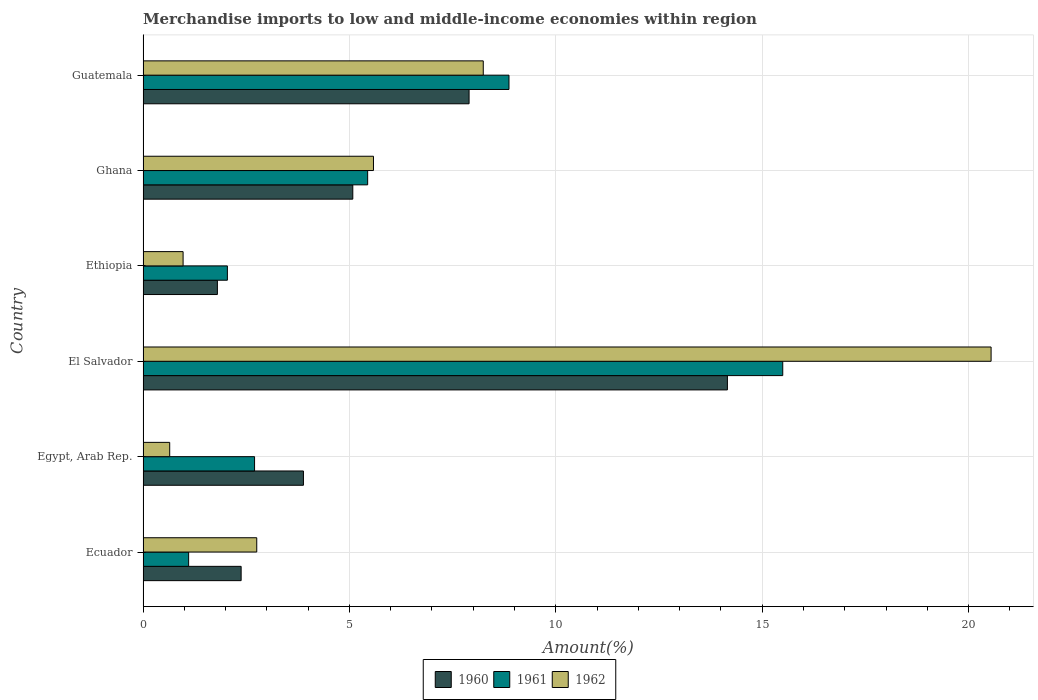Are the number of bars per tick equal to the number of legend labels?
Your response must be concise. Yes. Are the number of bars on each tick of the Y-axis equal?
Make the answer very short. Yes. How many bars are there on the 2nd tick from the bottom?
Provide a succinct answer. 3. What is the label of the 5th group of bars from the top?
Ensure brevity in your answer.  Egypt, Arab Rep. In how many cases, is the number of bars for a given country not equal to the number of legend labels?
Make the answer very short. 0. What is the percentage of amount earned from merchandise imports in 1961 in Ghana?
Offer a very short reply. 5.44. Across all countries, what is the maximum percentage of amount earned from merchandise imports in 1961?
Your answer should be very brief. 15.5. Across all countries, what is the minimum percentage of amount earned from merchandise imports in 1962?
Your answer should be very brief. 0.65. In which country was the percentage of amount earned from merchandise imports in 1961 maximum?
Provide a short and direct response. El Salvador. In which country was the percentage of amount earned from merchandise imports in 1962 minimum?
Your answer should be compact. Egypt, Arab Rep. What is the total percentage of amount earned from merchandise imports in 1960 in the graph?
Provide a short and direct response. 35.2. What is the difference between the percentage of amount earned from merchandise imports in 1961 in El Salvador and that in Ethiopia?
Keep it short and to the point. 13.46. What is the difference between the percentage of amount earned from merchandise imports in 1960 in El Salvador and the percentage of amount earned from merchandise imports in 1961 in Ethiopia?
Give a very brief answer. 12.11. What is the average percentage of amount earned from merchandise imports in 1960 per country?
Offer a very short reply. 5.87. What is the difference between the percentage of amount earned from merchandise imports in 1962 and percentage of amount earned from merchandise imports in 1960 in Ethiopia?
Offer a very short reply. -0.83. What is the ratio of the percentage of amount earned from merchandise imports in 1960 in Egypt, Arab Rep. to that in Ethiopia?
Offer a very short reply. 2.16. Is the percentage of amount earned from merchandise imports in 1960 in Egypt, Arab Rep. less than that in Ghana?
Provide a short and direct response. Yes. What is the difference between the highest and the second highest percentage of amount earned from merchandise imports in 1962?
Make the answer very short. 12.3. What is the difference between the highest and the lowest percentage of amount earned from merchandise imports in 1961?
Your answer should be compact. 14.39. In how many countries, is the percentage of amount earned from merchandise imports in 1961 greater than the average percentage of amount earned from merchandise imports in 1961 taken over all countries?
Your answer should be very brief. 2. Is the sum of the percentage of amount earned from merchandise imports in 1960 in Ecuador and Guatemala greater than the maximum percentage of amount earned from merchandise imports in 1962 across all countries?
Ensure brevity in your answer.  No. What does the 2nd bar from the bottom in El Salvador represents?
Provide a short and direct response. 1961. Is it the case that in every country, the sum of the percentage of amount earned from merchandise imports in 1961 and percentage of amount earned from merchandise imports in 1962 is greater than the percentage of amount earned from merchandise imports in 1960?
Provide a short and direct response. No. How many bars are there?
Your answer should be very brief. 18. How many countries are there in the graph?
Offer a terse response. 6. Does the graph contain any zero values?
Provide a short and direct response. No. How are the legend labels stacked?
Provide a short and direct response. Horizontal. What is the title of the graph?
Ensure brevity in your answer.  Merchandise imports to low and middle-income economies within region. What is the label or title of the X-axis?
Keep it short and to the point. Amount(%). What is the Amount(%) in 1960 in Ecuador?
Keep it short and to the point. 2.38. What is the Amount(%) in 1961 in Ecuador?
Provide a short and direct response. 1.1. What is the Amount(%) of 1962 in Ecuador?
Your answer should be compact. 2.75. What is the Amount(%) in 1960 in Egypt, Arab Rep.?
Give a very brief answer. 3.89. What is the Amount(%) of 1961 in Egypt, Arab Rep.?
Offer a terse response. 2.7. What is the Amount(%) in 1962 in Egypt, Arab Rep.?
Provide a short and direct response. 0.65. What is the Amount(%) of 1960 in El Salvador?
Provide a succinct answer. 14.16. What is the Amount(%) of 1961 in El Salvador?
Your answer should be compact. 15.5. What is the Amount(%) in 1962 in El Salvador?
Your response must be concise. 20.55. What is the Amount(%) of 1960 in Ethiopia?
Make the answer very short. 1.8. What is the Amount(%) of 1961 in Ethiopia?
Keep it short and to the point. 2.04. What is the Amount(%) of 1962 in Ethiopia?
Offer a terse response. 0.97. What is the Amount(%) in 1960 in Ghana?
Provide a succinct answer. 5.08. What is the Amount(%) of 1961 in Ghana?
Keep it short and to the point. 5.44. What is the Amount(%) in 1962 in Ghana?
Offer a very short reply. 5.58. What is the Amount(%) in 1960 in Guatemala?
Your answer should be compact. 7.9. What is the Amount(%) in 1961 in Guatemala?
Make the answer very short. 8.87. What is the Amount(%) of 1962 in Guatemala?
Provide a succinct answer. 8.24. Across all countries, what is the maximum Amount(%) in 1960?
Provide a short and direct response. 14.16. Across all countries, what is the maximum Amount(%) of 1961?
Offer a very short reply. 15.5. Across all countries, what is the maximum Amount(%) in 1962?
Offer a terse response. 20.55. Across all countries, what is the minimum Amount(%) in 1960?
Ensure brevity in your answer.  1.8. Across all countries, what is the minimum Amount(%) of 1961?
Provide a succinct answer. 1.1. Across all countries, what is the minimum Amount(%) in 1962?
Provide a short and direct response. 0.65. What is the total Amount(%) in 1960 in the graph?
Your answer should be compact. 35.2. What is the total Amount(%) of 1961 in the graph?
Make the answer very short. 35.65. What is the total Amount(%) of 1962 in the graph?
Offer a very short reply. 38.74. What is the difference between the Amount(%) of 1960 in Ecuador and that in Egypt, Arab Rep.?
Provide a short and direct response. -1.51. What is the difference between the Amount(%) of 1961 in Ecuador and that in Egypt, Arab Rep.?
Your response must be concise. -1.6. What is the difference between the Amount(%) in 1962 in Ecuador and that in Egypt, Arab Rep.?
Offer a very short reply. 2.11. What is the difference between the Amount(%) of 1960 in Ecuador and that in El Salvador?
Offer a terse response. -11.78. What is the difference between the Amount(%) in 1961 in Ecuador and that in El Salvador?
Provide a succinct answer. -14.39. What is the difference between the Amount(%) in 1962 in Ecuador and that in El Salvador?
Provide a succinct answer. -17.79. What is the difference between the Amount(%) of 1960 in Ecuador and that in Ethiopia?
Provide a succinct answer. 0.58. What is the difference between the Amount(%) in 1961 in Ecuador and that in Ethiopia?
Make the answer very short. -0.94. What is the difference between the Amount(%) in 1962 in Ecuador and that in Ethiopia?
Ensure brevity in your answer.  1.78. What is the difference between the Amount(%) of 1960 in Ecuador and that in Ghana?
Your answer should be very brief. -2.71. What is the difference between the Amount(%) in 1961 in Ecuador and that in Ghana?
Make the answer very short. -4.34. What is the difference between the Amount(%) in 1962 in Ecuador and that in Ghana?
Keep it short and to the point. -2.83. What is the difference between the Amount(%) of 1960 in Ecuador and that in Guatemala?
Provide a short and direct response. -5.52. What is the difference between the Amount(%) of 1961 in Ecuador and that in Guatemala?
Your answer should be very brief. -7.76. What is the difference between the Amount(%) of 1962 in Ecuador and that in Guatemala?
Your answer should be compact. -5.49. What is the difference between the Amount(%) in 1960 in Egypt, Arab Rep. and that in El Salvador?
Provide a short and direct response. -10.27. What is the difference between the Amount(%) of 1961 in Egypt, Arab Rep. and that in El Salvador?
Your answer should be very brief. -12.8. What is the difference between the Amount(%) in 1962 in Egypt, Arab Rep. and that in El Salvador?
Ensure brevity in your answer.  -19.9. What is the difference between the Amount(%) of 1960 in Egypt, Arab Rep. and that in Ethiopia?
Provide a short and direct response. 2.08. What is the difference between the Amount(%) in 1961 in Egypt, Arab Rep. and that in Ethiopia?
Provide a succinct answer. 0.66. What is the difference between the Amount(%) in 1962 in Egypt, Arab Rep. and that in Ethiopia?
Offer a very short reply. -0.32. What is the difference between the Amount(%) of 1960 in Egypt, Arab Rep. and that in Ghana?
Your answer should be very brief. -1.2. What is the difference between the Amount(%) in 1961 in Egypt, Arab Rep. and that in Ghana?
Your answer should be compact. -2.74. What is the difference between the Amount(%) of 1962 in Egypt, Arab Rep. and that in Ghana?
Your answer should be compact. -4.94. What is the difference between the Amount(%) in 1960 in Egypt, Arab Rep. and that in Guatemala?
Provide a short and direct response. -4.01. What is the difference between the Amount(%) in 1961 in Egypt, Arab Rep. and that in Guatemala?
Ensure brevity in your answer.  -6.16. What is the difference between the Amount(%) of 1962 in Egypt, Arab Rep. and that in Guatemala?
Make the answer very short. -7.6. What is the difference between the Amount(%) of 1960 in El Salvador and that in Ethiopia?
Give a very brief answer. 12.36. What is the difference between the Amount(%) of 1961 in El Salvador and that in Ethiopia?
Your answer should be compact. 13.46. What is the difference between the Amount(%) in 1962 in El Salvador and that in Ethiopia?
Your response must be concise. 19.58. What is the difference between the Amount(%) in 1960 in El Salvador and that in Ghana?
Give a very brief answer. 9.08. What is the difference between the Amount(%) in 1961 in El Salvador and that in Ghana?
Offer a very short reply. 10.06. What is the difference between the Amount(%) in 1962 in El Salvador and that in Ghana?
Your answer should be very brief. 14.96. What is the difference between the Amount(%) in 1960 in El Salvador and that in Guatemala?
Your response must be concise. 6.26. What is the difference between the Amount(%) of 1961 in El Salvador and that in Guatemala?
Keep it short and to the point. 6.63. What is the difference between the Amount(%) in 1962 in El Salvador and that in Guatemala?
Provide a succinct answer. 12.3. What is the difference between the Amount(%) of 1960 in Ethiopia and that in Ghana?
Keep it short and to the point. -3.28. What is the difference between the Amount(%) in 1961 in Ethiopia and that in Ghana?
Your response must be concise. -3.4. What is the difference between the Amount(%) of 1962 in Ethiopia and that in Ghana?
Give a very brief answer. -4.61. What is the difference between the Amount(%) in 1960 in Ethiopia and that in Guatemala?
Offer a terse response. -6.1. What is the difference between the Amount(%) of 1961 in Ethiopia and that in Guatemala?
Your response must be concise. -6.82. What is the difference between the Amount(%) in 1962 in Ethiopia and that in Guatemala?
Keep it short and to the point. -7.27. What is the difference between the Amount(%) in 1960 in Ghana and that in Guatemala?
Your answer should be very brief. -2.82. What is the difference between the Amount(%) of 1961 in Ghana and that in Guatemala?
Your answer should be compact. -3.42. What is the difference between the Amount(%) of 1962 in Ghana and that in Guatemala?
Provide a succinct answer. -2.66. What is the difference between the Amount(%) of 1960 in Ecuador and the Amount(%) of 1961 in Egypt, Arab Rep.?
Ensure brevity in your answer.  -0.33. What is the difference between the Amount(%) of 1960 in Ecuador and the Amount(%) of 1962 in Egypt, Arab Rep.?
Provide a short and direct response. 1.73. What is the difference between the Amount(%) in 1961 in Ecuador and the Amount(%) in 1962 in Egypt, Arab Rep.?
Provide a succinct answer. 0.46. What is the difference between the Amount(%) in 1960 in Ecuador and the Amount(%) in 1961 in El Salvador?
Your response must be concise. -13.12. What is the difference between the Amount(%) in 1960 in Ecuador and the Amount(%) in 1962 in El Salvador?
Your answer should be very brief. -18.17. What is the difference between the Amount(%) of 1961 in Ecuador and the Amount(%) of 1962 in El Salvador?
Your answer should be compact. -19.44. What is the difference between the Amount(%) of 1960 in Ecuador and the Amount(%) of 1961 in Ethiopia?
Offer a very short reply. 0.33. What is the difference between the Amount(%) in 1960 in Ecuador and the Amount(%) in 1962 in Ethiopia?
Ensure brevity in your answer.  1.41. What is the difference between the Amount(%) of 1961 in Ecuador and the Amount(%) of 1962 in Ethiopia?
Give a very brief answer. 0.13. What is the difference between the Amount(%) of 1960 in Ecuador and the Amount(%) of 1961 in Ghana?
Make the answer very short. -3.07. What is the difference between the Amount(%) in 1960 in Ecuador and the Amount(%) in 1962 in Ghana?
Make the answer very short. -3.21. What is the difference between the Amount(%) of 1961 in Ecuador and the Amount(%) of 1962 in Ghana?
Your answer should be very brief. -4.48. What is the difference between the Amount(%) in 1960 in Ecuador and the Amount(%) in 1961 in Guatemala?
Your answer should be very brief. -6.49. What is the difference between the Amount(%) in 1960 in Ecuador and the Amount(%) in 1962 in Guatemala?
Your answer should be compact. -5.87. What is the difference between the Amount(%) in 1961 in Ecuador and the Amount(%) in 1962 in Guatemala?
Your answer should be compact. -7.14. What is the difference between the Amount(%) of 1960 in Egypt, Arab Rep. and the Amount(%) of 1961 in El Salvador?
Offer a terse response. -11.61. What is the difference between the Amount(%) of 1960 in Egypt, Arab Rep. and the Amount(%) of 1962 in El Salvador?
Your response must be concise. -16.66. What is the difference between the Amount(%) in 1961 in Egypt, Arab Rep. and the Amount(%) in 1962 in El Salvador?
Provide a succinct answer. -17.84. What is the difference between the Amount(%) in 1960 in Egypt, Arab Rep. and the Amount(%) in 1961 in Ethiopia?
Provide a short and direct response. 1.84. What is the difference between the Amount(%) in 1960 in Egypt, Arab Rep. and the Amount(%) in 1962 in Ethiopia?
Keep it short and to the point. 2.92. What is the difference between the Amount(%) of 1961 in Egypt, Arab Rep. and the Amount(%) of 1962 in Ethiopia?
Provide a short and direct response. 1.73. What is the difference between the Amount(%) of 1960 in Egypt, Arab Rep. and the Amount(%) of 1961 in Ghana?
Make the answer very short. -1.56. What is the difference between the Amount(%) of 1960 in Egypt, Arab Rep. and the Amount(%) of 1962 in Ghana?
Make the answer very short. -1.7. What is the difference between the Amount(%) of 1961 in Egypt, Arab Rep. and the Amount(%) of 1962 in Ghana?
Your response must be concise. -2.88. What is the difference between the Amount(%) of 1960 in Egypt, Arab Rep. and the Amount(%) of 1961 in Guatemala?
Offer a very short reply. -4.98. What is the difference between the Amount(%) of 1960 in Egypt, Arab Rep. and the Amount(%) of 1962 in Guatemala?
Your response must be concise. -4.36. What is the difference between the Amount(%) in 1961 in Egypt, Arab Rep. and the Amount(%) in 1962 in Guatemala?
Provide a succinct answer. -5.54. What is the difference between the Amount(%) of 1960 in El Salvador and the Amount(%) of 1961 in Ethiopia?
Offer a terse response. 12.11. What is the difference between the Amount(%) of 1960 in El Salvador and the Amount(%) of 1962 in Ethiopia?
Provide a short and direct response. 13.19. What is the difference between the Amount(%) of 1961 in El Salvador and the Amount(%) of 1962 in Ethiopia?
Your answer should be very brief. 14.53. What is the difference between the Amount(%) of 1960 in El Salvador and the Amount(%) of 1961 in Ghana?
Give a very brief answer. 8.72. What is the difference between the Amount(%) of 1960 in El Salvador and the Amount(%) of 1962 in Ghana?
Keep it short and to the point. 8.57. What is the difference between the Amount(%) in 1961 in El Salvador and the Amount(%) in 1962 in Ghana?
Provide a succinct answer. 9.92. What is the difference between the Amount(%) of 1960 in El Salvador and the Amount(%) of 1961 in Guatemala?
Make the answer very short. 5.29. What is the difference between the Amount(%) in 1960 in El Salvador and the Amount(%) in 1962 in Guatemala?
Ensure brevity in your answer.  5.92. What is the difference between the Amount(%) in 1961 in El Salvador and the Amount(%) in 1962 in Guatemala?
Give a very brief answer. 7.26. What is the difference between the Amount(%) of 1960 in Ethiopia and the Amount(%) of 1961 in Ghana?
Give a very brief answer. -3.64. What is the difference between the Amount(%) in 1960 in Ethiopia and the Amount(%) in 1962 in Ghana?
Ensure brevity in your answer.  -3.78. What is the difference between the Amount(%) in 1961 in Ethiopia and the Amount(%) in 1962 in Ghana?
Make the answer very short. -3.54. What is the difference between the Amount(%) in 1960 in Ethiopia and the Amount(%) in 1961 in Guatemala?
Offer a terse response. -7.06. What is the difference between the Amount(%) of 1960 in Ethiopia and the Amount(%) of 1962 in Guatemala?
Provide a short and direct response. -6.44. What is the difference between the Amount(%) in 1961 in Ethiopia and the Amount(%) in 1962 in Guatemala?
Ensure brevity in your answer.  -6.2. What is the difference between the Amount(%) of 1960 in Ghana and the Amount(%) of 1961 in Guatemala?
Ensure brevity in your answer.  -3.78. What is the difference between the Amount(%) of 1960 in Ghana and the Amount(%) of 1962 in Guatemala?
Provide a short and direct response. -3.16. What is the difference between the Amount(%) in 1961 in Ghana and the Amount(%) in 1962 in Guatemala?
Give a very brief answer. -2.8. What is the average Amount(%) in 1960 per country?
Provide a short and direct response. 5.87. What is the average Amount(%) in 1961 per country?
Give a very brief answer. 5.94. What is the average Amount(%) in 1962 per country?
Make the answer very short. 6.46. What is the difference between the Amount(%) of 1960 and Amount(%) of 1961 in Ecuador?
Provide a short and direct response. 1.27. What is the difference between the Amount(%) in 1960 and Amount(%) in 1962 in Ecuador?
Give a very brief answer. -0.38. What is the difference between the Amount(%) of 1961 and Amount(%) of 1962 in Ecuador?
Your answer should be very brief. -1.65. What is the difference between the Amount(%) of 1960 and Amount(%) of 1961 in Egypt, Arab Rep.?
Give a very brief answer. 1.18. What is the difference between the Amount(%) of 1960 and Amount(%) of 1962 in Egypt, Arab Rep.?
Keep it short and to the point. 3.24. What is the difference between the Amount(%) of 1961 and Amount(%) of 1962 in Egypt, Arab Rep.?
Provide a short and direct response. 2.06. What is the difference between the Amount(%) of 1960 and Amount(%) of 1961 in El Salvador?
Your answer should be compact. -1.34. What is the difference between the Amount(%) of 1960 and Amount(%) of 1962 in El Salvador?
Offer a very short reply. -6.39. What is the difference between the Amount(%) of 1961 and Amount(%) of 1962 in El Salvador?
Offer a terse response. -5.05. What is the difference between the Amount(%) in 1960 and Amount(%) in 1961 in Ethiopia?
Offer a very short reply. -0.24. What is the difference between the Amount(%) of 1960 and Amount(%) of 1962 in Ethiopia?
Give a very brief answer. 0.83. What is the difference between the Amount(%) of 1961 and Amount(%) of 1962 in Ethiopia?
Provide a short and direct response. 1.07. What is the difference between the Amount(%) of 1960 and Amount(%) of 1961 in Ghana?
Keep it short and to the point. -0.36. What is the difference between the Amount(%) in 1960 and Amount(%) in 1962 in Ghana?
Ensure brevity in your answer.  -0.5. What is the difference between the Amount(%) of 1961 and Amount(%) of 1962 in Ghana?
Your response must be concise. -0.14. What is the difference between the Amount(%) of 1960 and Amount(%) of 1961 in Guatemala?
Offer a terse response. -0.97. What is the difference between the Amount(%) in 1960 and Amount(%) in 1962 in Guatemala?
Provide a succinct answer. -0.34. What is the difference between the Amount(%) of 1961 and Amount(%) of 1962 in Guatemala?
Provide a succinct answer. 0.62. What is the ratio of the Amount(%) of 1960 in Ecuador to that in Egypt, Arab Rep.?
Ensure brevity in your answer.  0.61. What is the ratio of the Amount(%) in 1961 in Ecuador to that in Egypt, Arab Rep.?
Make the answer very short. 0.41. What is the ratio of the Amount(%) in 1962 in Ecuador to that in Egypt, Arab Rep.?
Your answer should be very brief. 4.27. What is the ratio of the Amount(%) of 1960 in Ecuador to that in El Salvador?
Your response must be concise. 0.17. What is the ratio of the Amount(%) in 1961 in Ecuador to that in El Salvador?
Ensure brevity in your answer.  0.07. What is the ratio of the Amount(%) of 1962 in Ecuador to that in El Salvador?
Provide a succinct answer. 0.13. What is the ratio of the Amount(%) of 1960 in Ecuador to that in Ethiopia?
Provide a short and direct response. 1.32. What is the ratio of the Amount(%) in 1961 in Ecuador to that in Ethiopia?
Give a very brief answer. 0.54. What is the ratio of the Amount(%) of 1962 in Ecuador to that in Ethiopia?
Provide a short and direct response. 2.84. What is the ratio of the Amount(%) of 1960 in Ecuador to that in Ghana?
Keep it short and to the point. 0.47. What is the ratio of the Amount(%) in 1961 in Ecuador to that in Ghana?
Provide a succinct answer. 0.2. What is the ratio of the Amount(%) in 1962 in Ecuador to that in Ghana?
Offer a terse response. 0.49. What is the ratio of the Amount(%) of 1960 in Ecuador to that in Guatemala?
Provide a succinct answer. 0.3. What is the ratio of the Amount(%) in 1961 in Ecuador to that in Guatemala?
Provide a short and direct response. 0.12. What is the ratio of the Amount(%) of 1962 in Ecuador to that in Guatemala?
Your answer should be compact. 0.33. What is the ratio of the Amount(%) in 1960 in Egypt, Arab Rep. to that in El Salvador?
Offer a terse response. 0.27. What is the ratio of the Amount(%) of 1961 in Egypt, Arab Rep. to that in El Salvador?
Your response must be concise. 0.17. What is the ratio of the Amount(%) of 1962 in Egypt, Arab Rep. to that in El Salvador?
Provide a succinct answer. 0.03. What is the ratio of the Amount(%) of 1960 in Egypt, Arab Rep. to that in Ethiopia?
Provide a short and direct response. 2.16. What is the ratio of the Amount(%) in 1961 in Egypt, Arab Rep. to that in Ethiopia?
Your answer should be compact. 1.32. What is the ratio of the Amount(%) of 1962 in Egypt, Arab Rep. to that in Ethiopia?
Your answer should be compact. 0.67. What is the ratio of the Amount(%) in 1960 in Egypt, Arab Rep. to that in Ghana?
Provide a succinct answer. 0.76. What is the ratio of the Amount(%) in 1961 in Egypt, Arab Rep. to that in Ghana?
Provide a succinct answer. 0.5. What is the ratio of the Amount(%) in 1962 in Egypt, Arab Rep. to that in Ghana?
Ensure brevity in your answer.  0.12. What is the ratio of the Amount(%) in 1960 in Egypt, Arab Rep. to that in Guatemala?
Your answer should be compact. 0.49. What is the ratio of the Amount(%) of 1961 in Egypt, Arab Rep. to that in Guatemala?
Your response must be concise. 0.3. What is the ratio of the Amount(%) of 1962 in Egypt, Arab Rep. to that in Guatemala?
Your answer should be compact. 0.08. What is the ratio of the Amount(%) of 1960 in El Salvador to that in Ethiopia?
Offer a terse response. 7.86. What is the ratio of the Amount(%) in 1961 in El Salvador to that in Ethiopia?
Give a very brief answer. 7.59. What is the ratio of the Amount(%) of 1962 in El Salvador to that in Ethiopia?
Offer a very short reply. 21.18. What is the ratio of the Amount(%) of 1960 in El Salvador to that in Ghana?
Provide a short and direct response. 2.79. What is the ratio of the Amount(%) in 1961 in El Salvador to that in Ghana?
Your answer should be compact. 2.85. What is the ratio of the Amount(%) of 1962 in El Salvador to that in Ghana?
Your answer should be compact. 3.68. What is the ratio of the Amount(%) of 1960 in El Salvador to that in Guatemala?
Offer a very short reply. 1.79. What is the ratio of the Amount(%) of 1961 in El Salvador to that in Guatemala?
Offer a terse response. 1.75. What is the ratio of the Amount(%) in 1962 in El Salvador to that in Guatemala?
Your answer should be very brief. 2.49. What is the ratio of the Amount(%) of 1960 in Ethiopia to that in Ghana?
Your answer should be very brief. 0.35. What is the ratio of the Amount(%) in 1961 in Ethiopia to that in Ghana?
Provide a short and direct response. 0.38. What is the ratio of the Amount(%) in 1962 in Ethiopia to that in Ghana?
Offer a very short reply. 0.17. What is the ratio of the Amount(%) in 1960 in Ethiopia to that in Guatemala?
Your answer should be compact. 0.23. What is the ratio of the Amount(%) of 1961 in Ethiopia to that in Guatemala?
Provide a succinct answer. 0.23. What is the ratio of the Amount(%) in 1962 in Ethiopia to that in Guatemala?
Provide a succinct answer. 0.12. What is the ratio of the Amount(%) of 1960 in Ghana to that in Guatemala?
Your response must be concise. 0.64. What is the ratio of the Amount(%) in 1961 in Ghana to that in Guatemala?
Offer a terse response. 0.61. What is the ratio of the Amount(%) of 1962 in Ghana to that in Guatemala?
Give a very brief answer. 0.68. What is the difference between the highest and the second highest Amount(%) in 1960?
Your response must be concise. 6.26. What is the difference between the highest and the second highest Amount(%) of 1961?
Your answer should be very brief. 6.63. What is the difference between the highest and the second highest Amount(%) of 1962?
Offer a very short reply. 12.3. What is the difference between the highest and the lowest Amount(%) in 1960?
Your answer should be very brief. 12.36. What is the difference between the highest and the lowest Amount(%) in 1961?
Make the answer very short. 14.39. What is the difference between the highest and the lowest Amount(%) of 1962?
Provide a succinct answer. 19.9. 